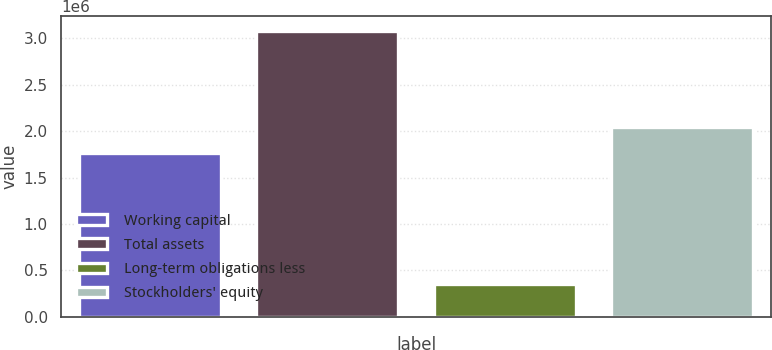Convert chart to OTSL. <chart><loc_0><loc_0><loc_500><loc_500><bar_chart><fcel>Working capital<fcel>Total assets<fcel>Long-term obligations less<fcel>Stockholders' equity<nl><fcel>1.76799e+06<fcel>3.08378e+06<fcel>355050<fcel>2.04086e+06<nl></chart> 